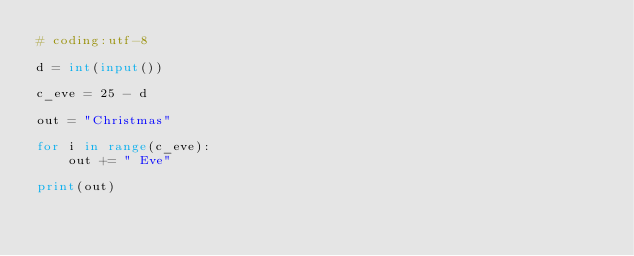Convert code to text. <code><loc_0><loc_0><loc_500><loc_500><_Python_># coding:utf-8

d = int(input())

c_eve = 25 - d

out = "Christmas"

for i in range(c_eve):
    out += " Eve"

print(out)</code> 